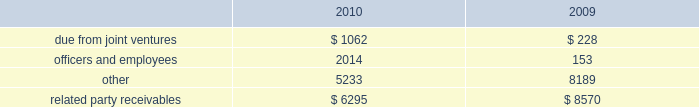Amounts due from related parties at december a031 , 2010 and 2009 con- sisted of the following ( in thousands ) : .
Gramercy capital corp .
See note a0 6 , 201cinvestment in unconsolidated joint ventures 2014gramercy capital corp. , 201d for disclosure on related party transactions between gramercy and the company .
13 2002equit y common stock our authorized capital stock consists of 260000000 shares , $ .01 par value , of which we have authorized the issuance of up to 160000000 shares of common stock , $ .01 par value per share , 75000000 shares of excess stock , $ .01 par value per share , and 25000000 shares of preferred stock , $ .01 par value per share .
As of december a031 , 2010 , 78306702 shares of common stock and no shares of excess stock were issued and outstanding .
In may 2009 , we sold 19550000 shares of our common stock at a gross price of $ 20.75 per share .
The net proceeds from this offer- ing ( approximately $ 387.1 a0 million ) were primarily used to repurchase unsecured debt .
Perpetual preferred stock in january 2010 , we sold 5400000 shares of our series a0c preferred stock in an underwritten public offering .
As a result of this offering , we have 11700000 shares of the series a0 c preferred stock outstanding .
The shares of series a0c preferred stock have a liquidation preference of $ 25.00 per share and are redeemable at par , plus accrued and unpaid dividends , at any time at our option .
The shares were priced at $ 23.53 per share including accrued dividends equating to a yield of 8.101% ( 8.101 % ) .
We used the net offering proceeds of approximately $ 122.0 a0million for gen- eral corporate and/or working capital purposes , including purchases of the indebtedness of our subsidiaries and investment opportunities .
In december 2003 , we sold 6300000 shares of our 7.625% ( 7.625 % ) series a0 c preferred stock , ( including the underwriters 2019 over-allotment option of 700000 shares ) with a mandatory liquidation preference of $ 25.00 per share .
Net proceeds from this offering ( approximately $ 152.0 a0 million ) were used principally to repay amounts outstanding under our secured and unsecured revolving credit facilities .
The series a0c preferred stockholders receive annual dividends of $ 1.90625 per share paid on a quarterly basis and dividends are cumulative , subject to cer- tain provisions .
Since december a0 12 , 2008 , we have been entitled to redeem the series a0c preferred stock at par for cash at our option .
The series a0c preferred stock was recorded net of underwriters discount and issuance costs .
12 2002related part y transactions cleaning/securit y/messenger and restoration services through al l iance bui lding services , or al l iance , first qual i t y maintenance , a0l.p. , or first quality , provides cleaning , extermination and related services , classic security a0llc provides security services , bright star couriers a0llc provides messenger services , and onyx restoration works provides restoration services with respect to certain proper- ties owned by us .
Alliance is partially owned by gary green , a son of stephen a0l .
Green , the chairman of our board of directors .
In addition , first quality has the non-exclusive opportunity to provide cleaning and related services to individual tenants at our properties on a basis sepa- rately negotiated with any tenant seeking such additional services .
The service corp .
Has entered into an arrangement with alliance whereby it will receive a profit participation above a certain threshold for services provided by alliance to certain tenants at certain buildings above the base services specified in their lease agreements .
Alliance paid the service corporation approximately $ 2.2 a0million , $ 1.8 a0million and $ 1.4 a0million for the years ended december a031 , 2010 , 2009 and 2008 , respectively .
We paid alliance approximately $ 14.2 a0million , $ 14.9 a0million and $ 15.1 a0million for three years ended december a031 , 2010 , respectively , for these ser- vices ( excluding services provided directly to tenants ) .
Leases nancy peck and company leases 1003 square feet of space at 420 lexington avenue under a lease that ends in august 2015 .
Nancy peck and company is owned by nancy peck , the wife of stephen a0l .
Green .
The rent due pursuant to the lease is $ 35516 per annum for year one increas- ing to $ 40000 in year seven .
From february 2007 through december 2008 , nancy peck and company leased 507 square feet of space at 420 a0 lexington avenue pursuant to a lease which provided for annual rental payments of approximately $ 15210 .
Brokerage services cushman a0 & wakefield sonnenblick-goldman , a0 llc , or sonnenblick , a nationally recognized real estate investment banking firm , provided mortgage brokerage services to us .
Mr . a0 morton holliday , the father of mr . a0 marc holliday , was a managing director of sonnenblick at the time of the financings .
In 2009 , we paid approximately $ 428000 to sonnenblick in connection with the purchase of a sub-leasehold interest and the refinancing of 420 lexington avenue .
Management fees s.l .
Green management corp. , a consolidated entity , receives property management fees from an entity in which stephen a0l .
Green owns an inter- est .
The aggregate amount of fees paid to s.l .
Green management corp .
From such entity was approximately $ 390700 in 2010 , $ 351700 in 2009 and $ 353500 in 2008 .
Notes to consolidated financial statements .
What was the total paid to alliance from 2008-2010 , in millions? 
Computations: ((14.2 + 14.9) + 15.1)
Answer: 44.2. 